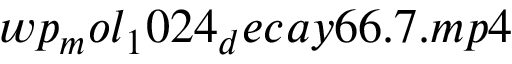Convert formula to latex. <formula><loc_0><loc_0><loc_500><loc_500>w p _ { m } o l _ { 1 } 0 2 4 _ { d } e c a y 6 6 . 7 . m p 4</formula> 